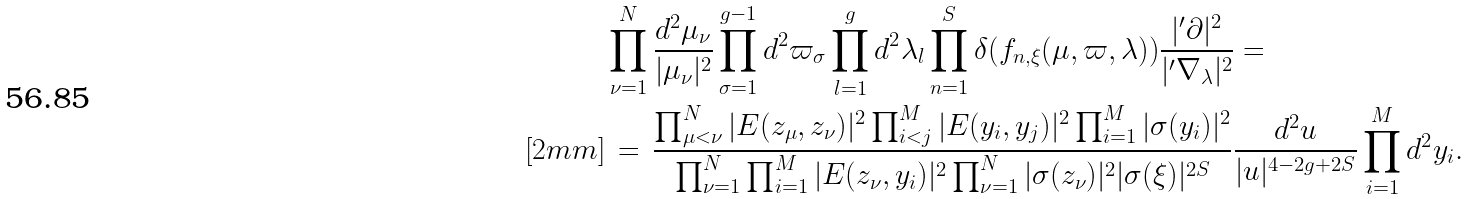<formula> <loc_0><loc_0><loc_500><loc_500>& \prod _ { \nu = 1 } ^ { N } \frac { d ^ { 2 } \mu _ { \nu } } { | \mu _ { \nu } | ^ { 2 } } \prod _ { \sigma = 1 } ^ { g - 1 } d ^ { 2 } \varpi _ { \sigma } \prod _ { l = 1 } ^ { g } d ^ { 2 } \lambda _ { l } \prod _ { n = 1 } ^ { S } \delta ( f _ { n , \xi } ( \mu , \varpi , \lambda ) ) \frac { | ^ { \prime } \partial | ^ { 2 } } { | ^ { \prime } \nabla _ { \lambda } | ^ { 2 } } = \\ [ 2 m m ] & \, = \, \frac { \prod _ { \mu < \nu } ^ { N } | E ( z _ { \mu } , z _ { \nu } ) | ^ { 2 } \prod _ { i < j } ^ { M } | E ( y _ { i } , y _ { j } ) | ^ { 2 } \prod _ { i = 1 } ^ { M } | \sigma ( y _ { i } ) | ^ { 2 } } { \prod _ { \nu = 1 } ^ { N } \prod _ { i = 1 } ^ { M } | E ( z _ { \nu } , y _ { i } ) | ^ { 2 } \prod _ { \nu = 1 } ^ { N } | \sigma ( z _ { \nu } ) | ^ { 2 } | \sigma ( \xi ) | ^ { 2 S } } \frac { d ^ { 2 } u } { | u | ^ { 4 - 2 g + 2 S } } \prod _ { i = 1 } ^ { M } d ^ { 2 } y _ { i } .</formula> 